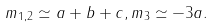Convert formula to latex. <formula><loc_0><loc_0><loc_500><loc_500>m _ { 1 , 2 } \simeq a + b + c , m _ { 3 } \simeq - 3 a .</formula> 